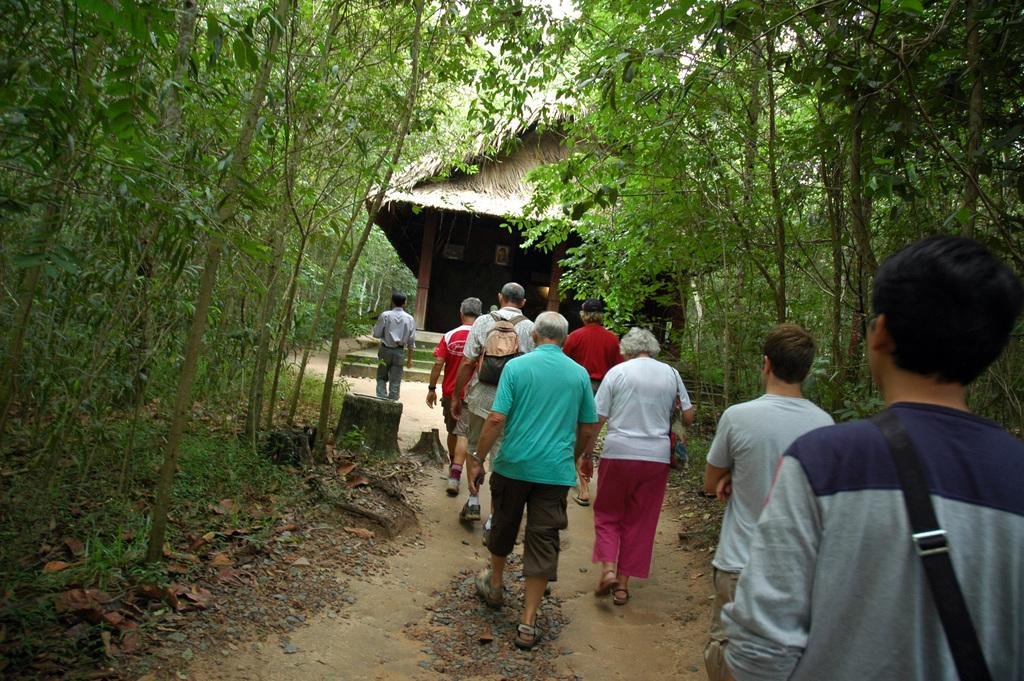What are the people in the image doing? The people in the image are walking on the path of a road. What can be seen in front of the people? There is a house in front of the people. What type of vegetation is present on either side of the road? There are trees on either side of the road. What else can be seen on the ground near the trees? Dried leaves are present on either side of the road. What type of net can be seen hanging from the trees in the image? There is no net present in the image; it only features people walking, a house, trees, and dried leaves. 